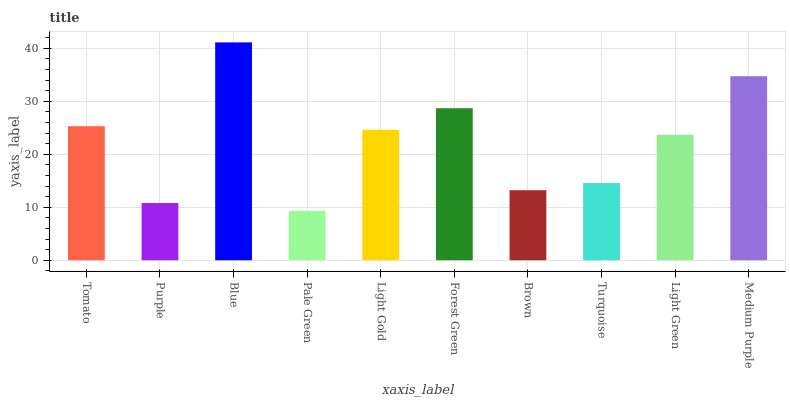Is Pale Green the minimum?
Answer yes or no. Yes. Is Blue the maximum?
Answer yes or no. Yes. Is Purple the minimum?
Answer yes or no. No. Is Purple the maximum?
Answer yes or no. No. Is Tomato greater than Purple?
Answer yes or no. Yes. Is Purple less than Tomato?
Answer yes or no. Yes. Is Purple greater than Tomato?
Answer yes or no. No. Is Tomato less than Purple?
Answer yes or no. No. Is Light Gold the high median?
Answer yes or no. Yes. Is Light Green the low median?
Answer yes or no. Yes. Is Blue the high median?
Answer yes or no. No. Is Light Gold the low median?
Answer yes or no. No. 